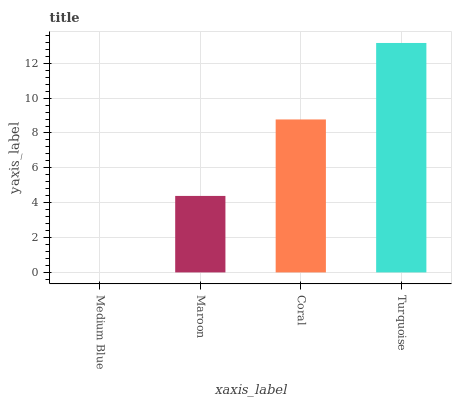Is Maroon the minimum?
Answer yes or no. No. Is Maroon the maximum?
Answer yes or no. No. Is Maroon greater than Medium Blue?
Answer yes or no. Yes. Is Medium Blue less than Maroon?
Answer yes or no. Yes. Is Medium Blue greater than Maroon?
Answer yes or no. No. Is Maroon less than Medium Blue?
Answer yes or no. No. Is Coral the high median?
Answer yes or no. Yes. Is Maroon the low median?
Answer yes or no. Yes. Is Turquoise the high median?
Answer yes or no. No. Is Turquoise the low median?
Answer yes or no. No. 